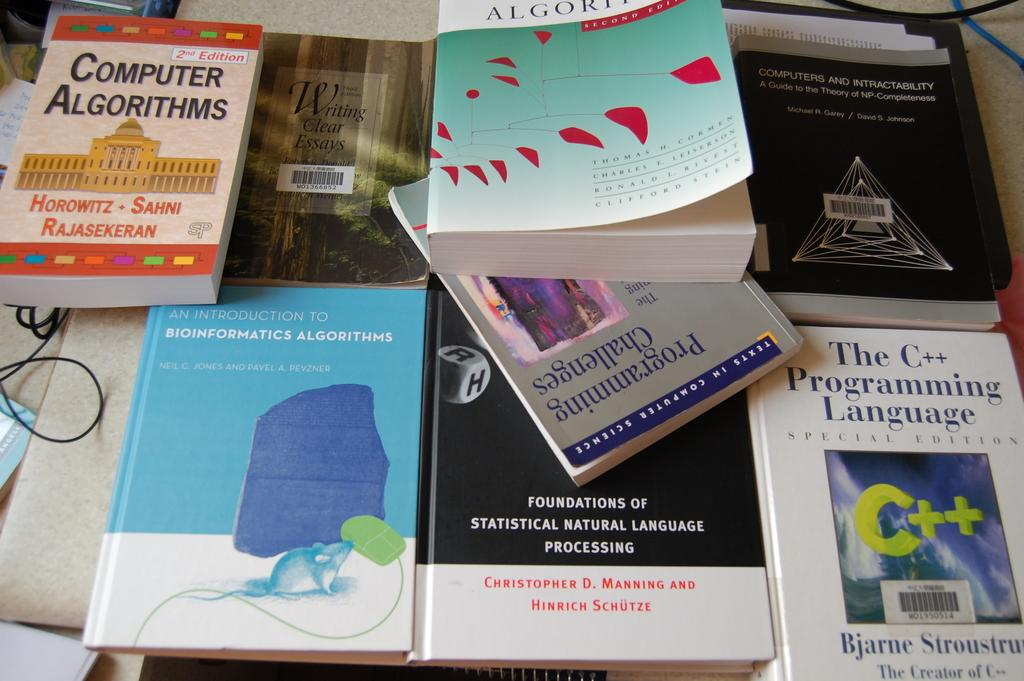<image>
Relay a brief, clear account of the picture shown. Several educational books on computer algorithms are strewn across a table. 